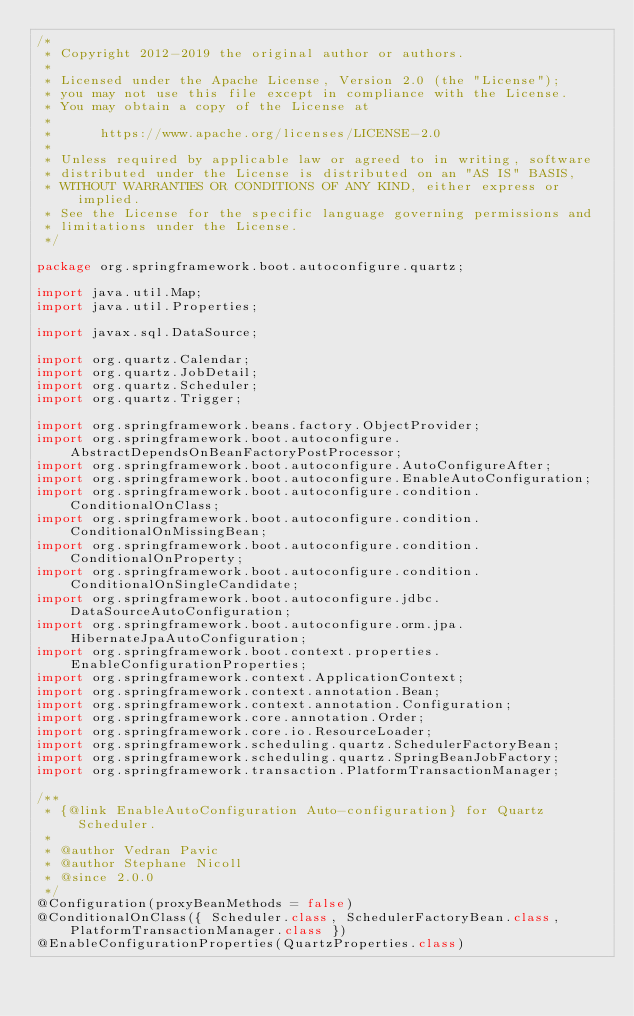Convert code to text. <code><loc_0><loc_0><loc_500><loc_500><_Java_>/*
 * Copyright 2012-2019 the original author or authors.
 *
 * Licensed under the Apache License, Version 2.0 (the "License");
 * you may not use this file except in compliance with the License.
 * You may obtain a copy of the License at
 *
 *      https://www.apache.org/licenses/LICENSE-2.0
 *
 * Unless required by applicable law or agreed to in writing, software
 * distributed under the License is distributed on an "AS IS" BASIS,
 * WITHOUT WARRANTIES OR CONDITIONS OF ANY KIND, either express or implied.
 * See the License for the specific language governing permissions and
 * limitations under the License.
 */

package org.springframework.boot.autoconfigure.quartz;

import java.util.Map;
import java.util.Properties;

import javax.sql.DataSource;

import org.quartz.Calendar;
import org.quartz.JobDetail;
import org.quartz.Scheduler;
import org.quartz.Trigger;

import org.springframework.beans.factory.ObjectProvider;
import org.springframework.boot.autoconfigure.AbstractDependsOnBeanFactoryPostProcessor;
import org.springframework.boot.autoconfigure.AutoConfigureAfter;
import org.springframework.boot.autoconfigure.EnableAutoConfiguration;
import org.springframework.boot.autoconfigure.condition.ConditionalOnClass;
import org.springframework.boot.autoconfigure.condition.ConditionalOnMissingBean;
import org.springframework.boot.autoconfigure.condition.ConditionalOnProperty;
import org.springframework.boot.autoconfigure.condition.ConditionalOnSingleCandidate;
import org.springframework.boot.autoconfigure.jdbc.DataSourceAutoConfiguration;
import org.springframework.boot.autoconfigure.orm.jpa.HibernateJpaAutoConfiguration;
import org.springframework.boot.context.properties.EnableConfigurationProperties;
import org.springframework.context.ApplicationContext;
import org.springframework.context.annotation.Bean;
import org.springframework.context.annotation.Configuration;
import org.springframework.core.annotation.Order;
import org.springframework.core.io.ResourceLoader;
import org.springframework.scheduling.quartz.SchedulerFactoryBean;
import org.springframework.scheduling.quartz.SpringBeanJobFactory;
import org.springframework.transaction.PlatformTransactionManager;

/**
 * {@link EnableAutoConfiguration Auto-configuration} for Quartz Scheduler.
 *
 * @author Vedran Pavic
 * @author Stephane Nicoll
 * @since 2.0.0
 */
@Configuration(proxyBeanMethods = false)
@ConditionalOnClass({ Scheduler.class, SchedulerFactoryBean.class, PlatformTransactionManager.class })
@EnableConfigurationProperties(QuartzProperties.class)</code> 